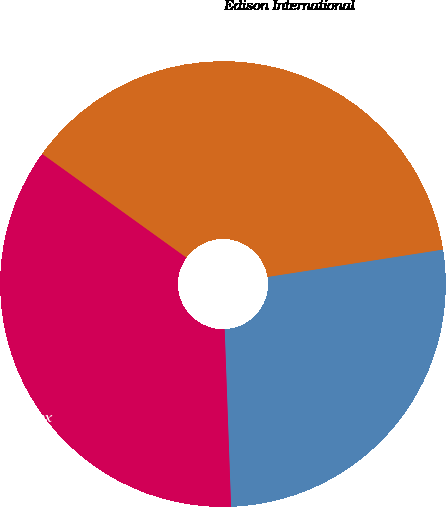<chart> <loc_0><loc_0><loc_500><loc_500><pie_chart><fcel>Edison International<fcel>S & P 500 Index<fcel>Philadelphia Utility Index<nl><fcel>37.61%<fcel>26.89%<fcel>35.5%<nl></chart> 